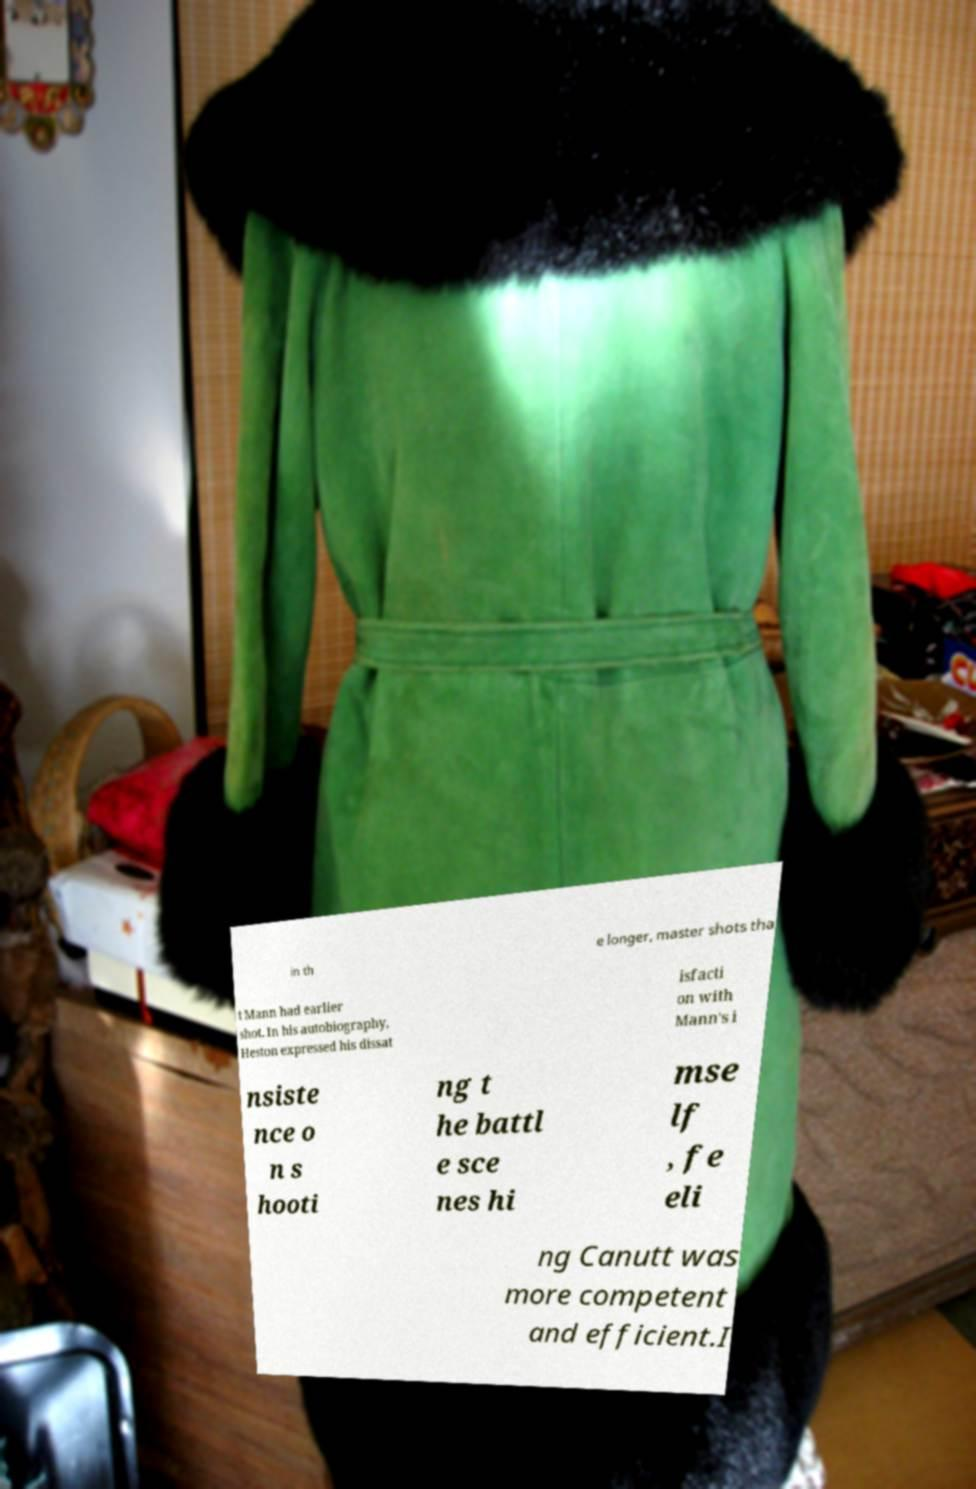For documentation purposes, I need the text within this image transcribed. Could you provide that? in th e longer, master shots tha t Mann had earlier shot. In his autobiography, Heston expressed his dissat isfacti on with Mann's i nsiste nce o n s hooti ng t he battl e sce nes hi mse lf , fe eli ng Canutt was more competent and efficient.I 